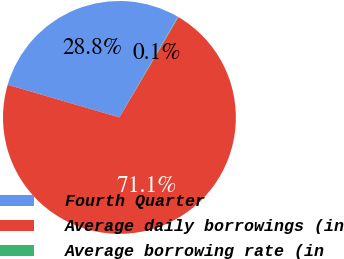Convert chart to OTSL. <chart><loc_0><loc_0><loc_500><loc_500><pie_chart><fcel>Fourth Quarter<fcel>Average daily borrowings (in<fcel>Average borrowing rate (in<nl><fcel>28.83%<fcel>71.08%<fcel>0.1%<nl></chart> 